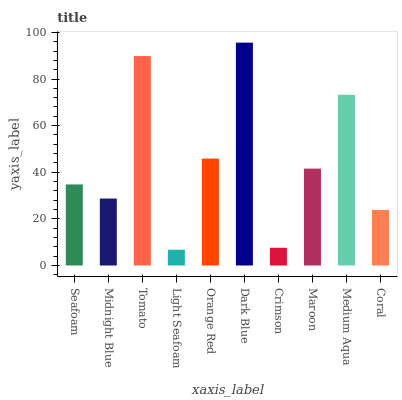Is Light Seafoam the minimum?
Answer yes or no. Yes. Is Dark Blue the maximum?
Answer yes or no. Yes. Is Midnight Blue the minimum?
Answer yes or no. No. Is Midnight Blue the maximum?
Answer yes or no. No. Is Seafoam greater than Midnight Blue?
Answer yes or no. Yes. Is Midnight Blue less than Seafoam?
Answer yes or no. Yes. Is Midnight Blue greater than Seafoam?
Answer yes or no. No. Is Seafoam less than Midnight Blue?
Answer yes or no. No. Is Maroon the high median?
Answer yes or no. Yes. Is Seafoam the low median?
Answer yes or no. Yes. Is Light Seafoam the high median?
Answer yes or no. No. Is Tomato the low median?
Answer yes or no. No. 